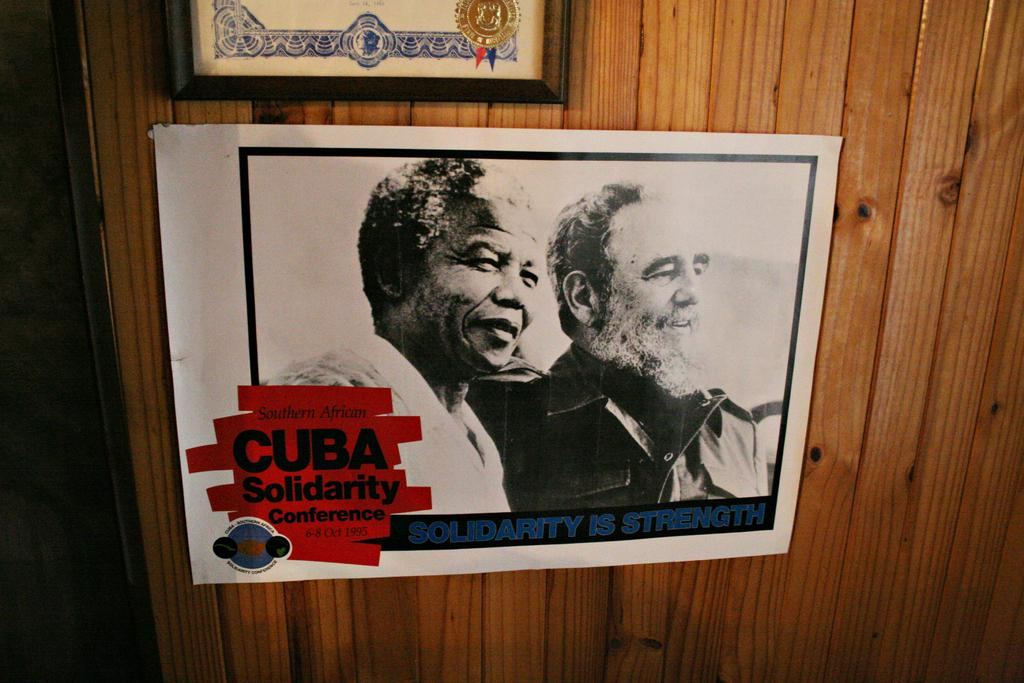What is attached to the wooden wall in the image? There is a paper attached to the wooden wall in the image. What is unique about the paper's presentation? The paper has a frame around it. What is depicted on the paper? The paper contains an image of two people. Is there any text on the paper? Yes, there is writing on the paper. What type of food is being rubbed on the stem of the plant in the image? There is no plant or food present in the image; it features a paper with an image of two people and writing. 